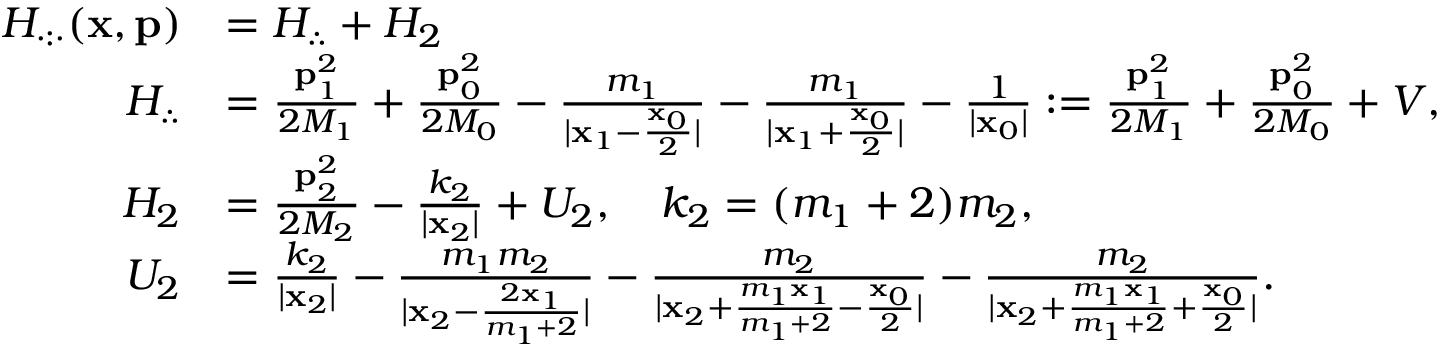Convert formula to latex. <formula><loc_0><loc_0><loc_500><loc_500>\begin{array} { r l } { H _ { \cdot \colon \cdot } ( x , p ) } & { = H _ { \therefore } + H _ { 2 } } \\ { H _ { \therefore } } & { = \frac { p _ { 1 } ^ { 2 } } { 2 M _ { 1 } } + \frac { p _ { 0 } ^ { 2 } } { 2 M _ { 0 } } - \frac { m _ { 1 } } { | x _ { 1 } - \frac { x _ { 0 } } { 2 } | } - \frac { m _ { 1 } } { | x _ { 1 } + \frac { x _ { 0 } } { 2 } | } - \frac { 1 } { | x _ { 0 } | } \colon = \frac { p _ { 1 } ^ { 2 } } { 2 M _ { 1 } } + \frac { p _ { 0 } ^ { 2 } } { 2 M _ { 0 } } + V , } \\ { H _ { 2 } } & { = \frac { p _ { 2 } ^ { 2 } } { 2 M _ { 2 } } - \frac { k _ { 2 } } { | x _ { 2 } | } + U _ { 2 } , \quad k _ { 2 } = ( m _ { 1 } + 2 ) m _ { 2 } , } \\ { U _ { 2 } } & { = \frac { k _ { 2 } } { | x _ { 2 } | } - \frac { m _ { 1 } m _ { 2 } } { | x _ { 2 } - \frac { 2 x _ { 1 } } { m _ { 1 } + 2 } | } - \frac { m _ { 2 } } { | x _ { 2 } + \frac { m _ { 1 } x _ { 1 } } { m _ { 1 } + 2 } - \frac { x _ { 0 } } { 2 } | } - \frac { m _ { 2 } } { | x _ { 2 } + \frac { m _ { 1 } x _ { 1 } } { m _ { 1 } + 2 } + \frac { x _ { 0 } } { 2 } | } . } \end{array}</formula> 